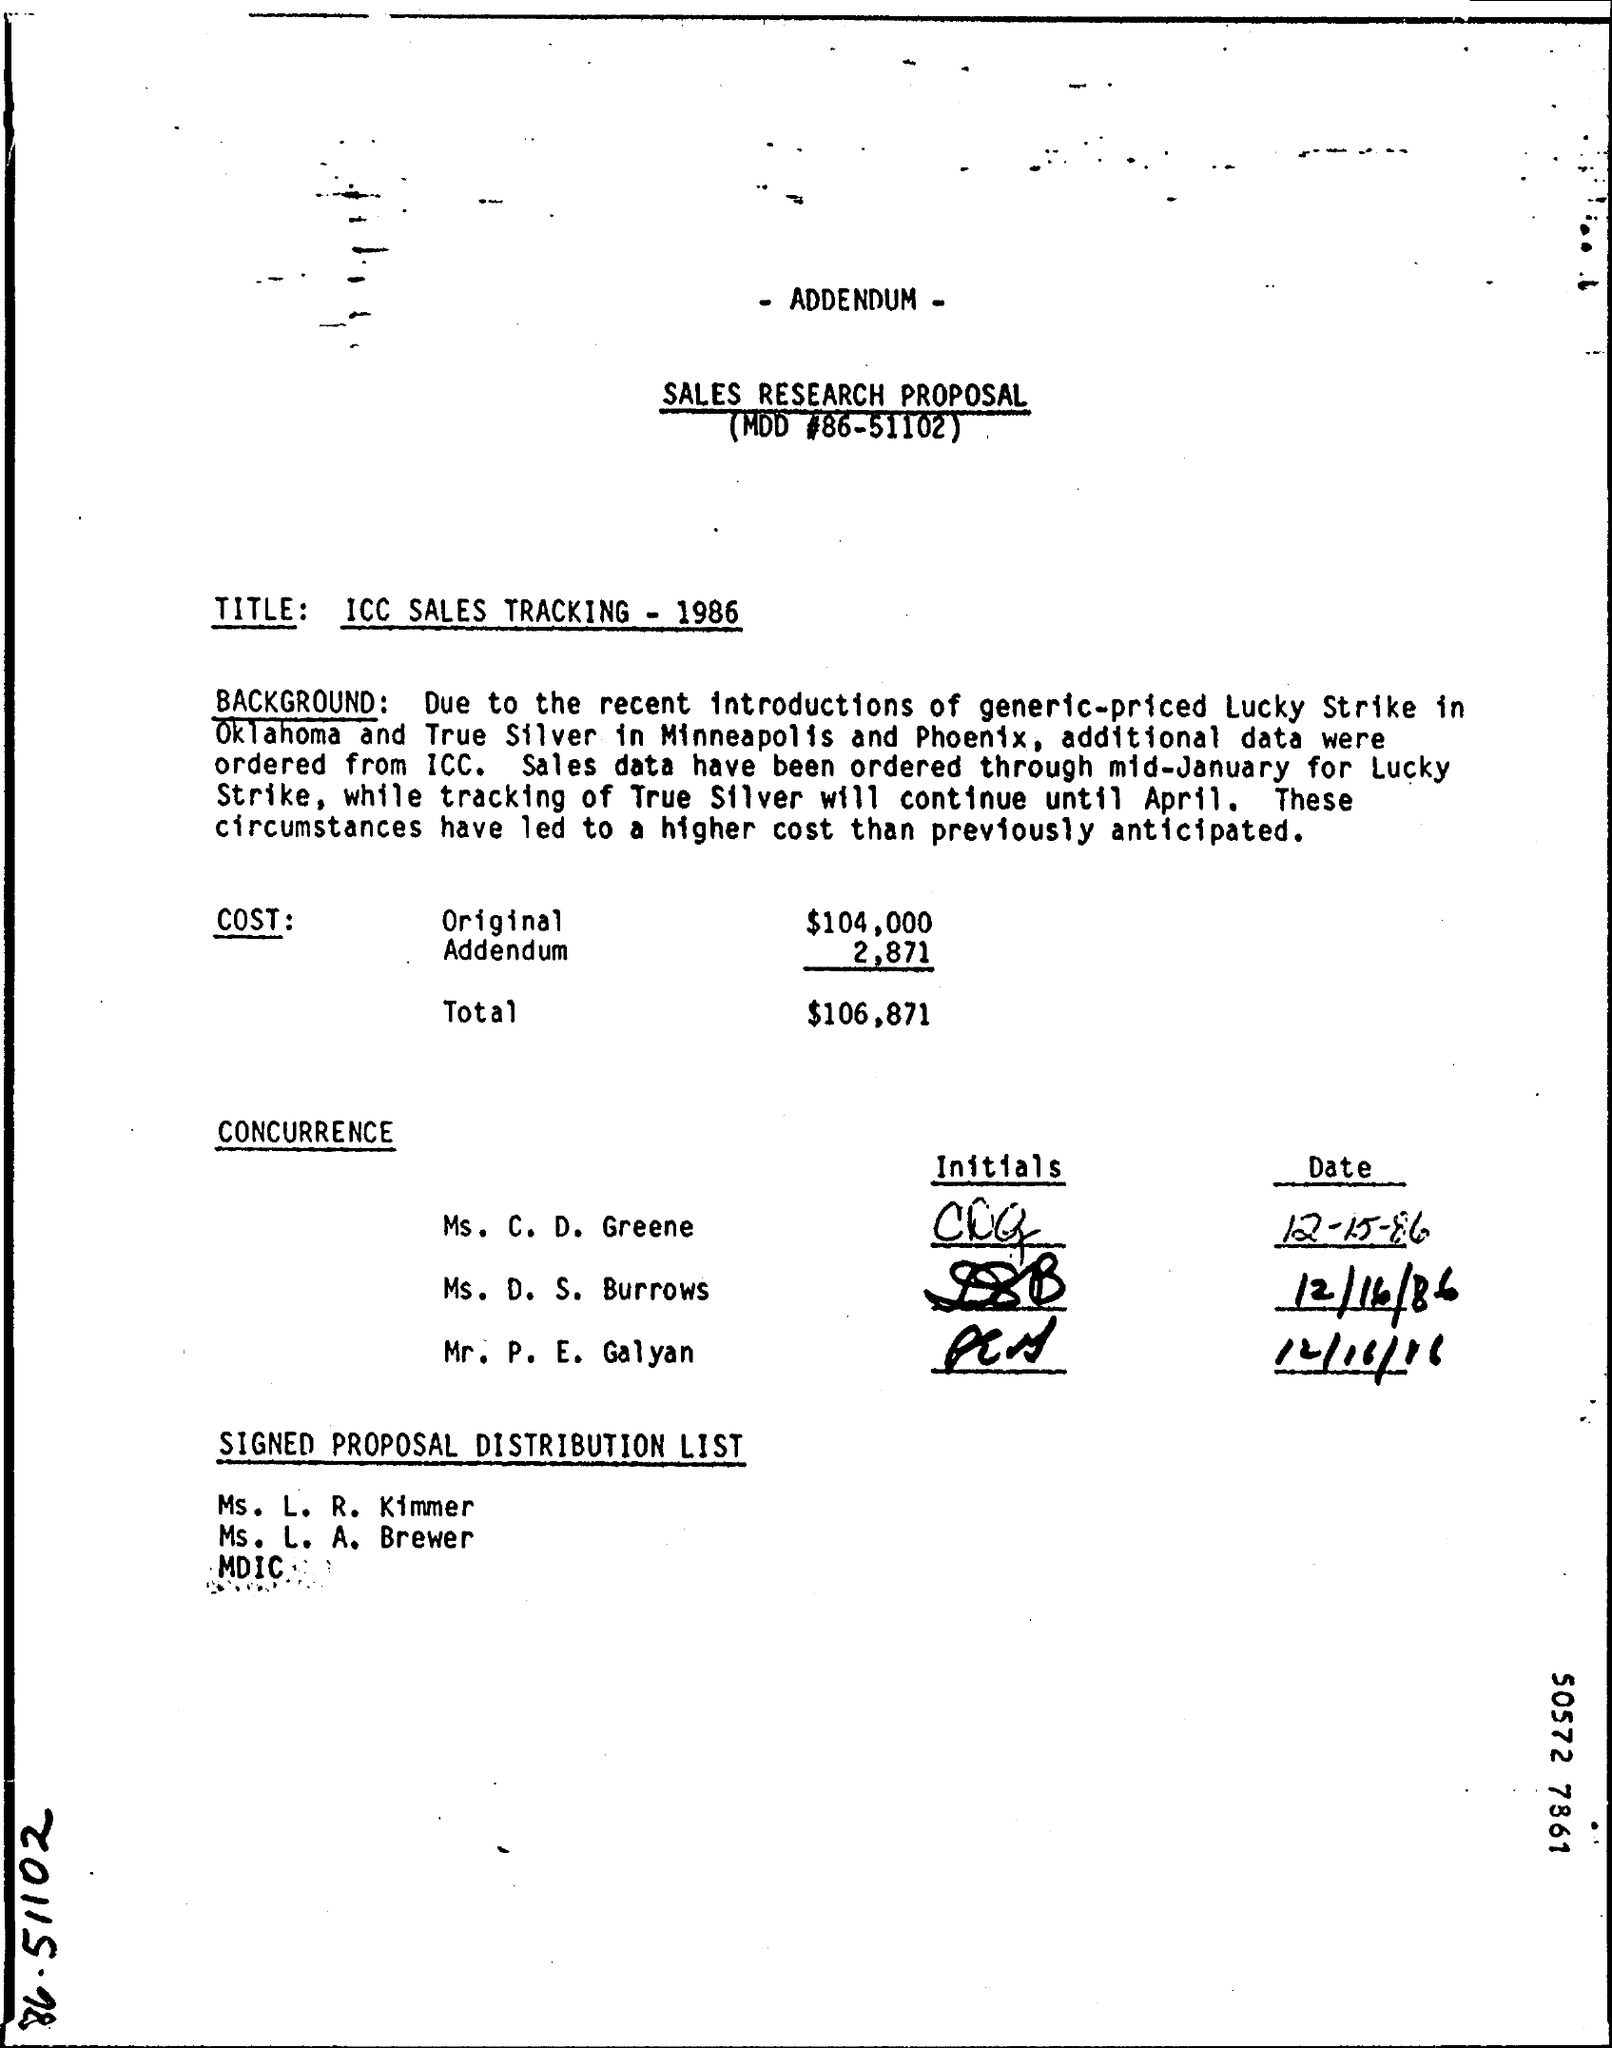What is the 'Addendum' mentioned and what could it entail? The 'Addendum' noted in the document alongside an associated cost might be amendments or additional items that were not originally planned in the sales research proposal. This could involve further data collection or an unexpected expansion of the research scope that incurred additional costs. What might have prompted the need for an addendum? Potential prompts for an addendum could include unanticipated market changes, such as the introduction of competing products, or a need for more comprehensive data to better understand market dynamics or the impact of strategic decisions. 